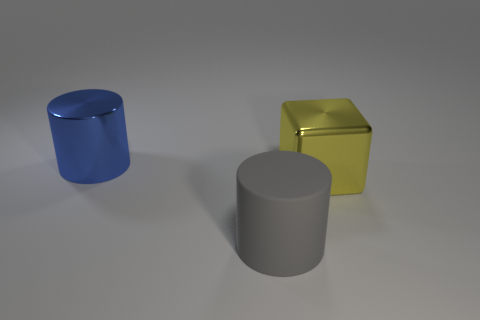What is the gray cylinder made of?
Ensure brevity in your answer.  Rubber. The big blue metallic object is what shape?
Keep it short and to the point. Cylinder. What number of metallic objects are the same color as the large cube?
Your response must be concise. 0. The big cylinder that is behind the big cylinder right of the large blue metallic object that is to the left of the big yellow cube is made of what material?
Your response must be concise. Metal. How many red things are either matte cylinders or shiny cylinders?
Provide a short and direct response. 0. What size is the cylinder on the right side of the large shiny object to the left of the large cylinder in front of the yellow metal block?
Provide a short and direct response. Large. There is another rubber thing that is the same shape as the blue object; what is its size?
Your answer should be compact. Large. What number of big objects are either metallic things or yellow matte balls?
Keep it short and to the point. 2. Is the material of the cylinder to the right of the large metallic cylinder the same as the cylinder that is behind the big rubber cylinder?
Your answer should be compact. No. There is a thing that is left of the matte cylinder; what is its material?
Provide a short and direct response. Metal. 